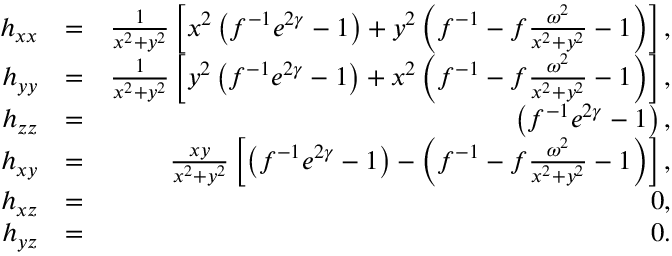<formula> <loc_0><loc_0><loc_500><loc_500>\begin{array} { r l r } { h _ { x x } } & { = } & { \frac { 1 } { x ^ { 2 } + y ^ { 2 } } \left [ x ^ { 2 } \left ( f ^ { - 1 } e ^ { 2 \gamma } - 1 \right ) + y ^ { 2 } \left ( f ^ { - 1 } - f \frac { \omega ^ { 2 } } { x ^ { 2 } + y ^ { 2 } } - 1 \right ) \right ] , } \\ { h _ { y y } } & { = } & { \frac { 1 } { x ^ { 2 } + y ^ { 2 } } \left [ y ^ { 2 } \left ( f ^ { - 1 } e ^ { 2 \gamma } - 1 \right ) + x ^ { 2 } \left ( f ^ { - 1 } - f \frac { \omega ^ { 2 } } { x ^ { 2 } + y ^ { 2 } } - 1 \right ) \right ] , } \\ { h _ { z z } } & { = } & { \left ( f ^ { - 1 } e ^ { 2 \gamma } - 1 \right ) , } \\ { h _ { x y } } & { = } & { \frac { x y } { x ^ { 2 } + y ^ { 2 } } \left [ \left ( f ^ { - 1 } e ^ { 2 \gamma } - 1 \right ) - \left ( f ^ { - 1 } - f \frac { \omega ^ { 2 } } { x ^ { 2 } + y ^ { 2 } } - 1 \right ) \right ] , } \\ { h _ { x z } } & { = } & { 0 , } \\ { h _ { y z } } & { = } & { 0 . } \end{array}</formula> 